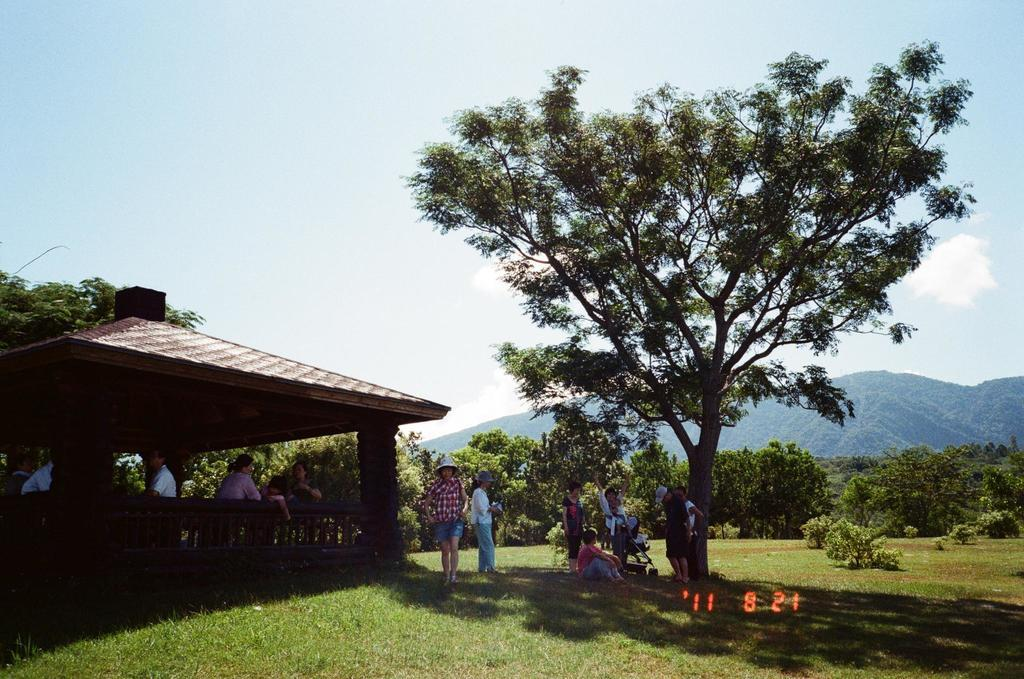What type of vegetation can be seen in the image? There is grass and plants in the image. Can you describe the people in the image? There is a group of people in the image. What type of structure is present in the image? There is a gazebo in the image. What other natural elements can be seen in the image? There are trees and hills in the image. What is visible in the background of the image? The sky is visible in the background of the image. What theory do the plants in the image support? The image does not present any theories, and the plants are not related to any theories. How does the behavior of the people in the image change over time? The image is a static representation and does not show any changes in behavior over time. 